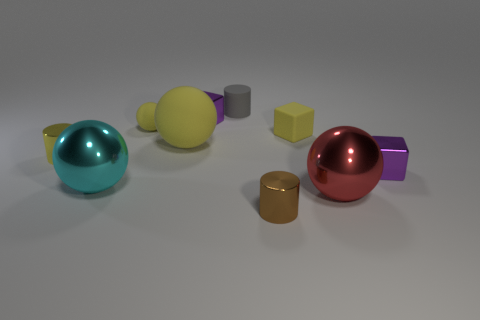There is a big object that is to the left of the large red sphere and in front of the big yellow rubber thing; what material is it made of?
Ensure brevity in your answer.  Metal. What shape is the gray matte object that is the same size as the brown metallic object?
Offer a terse response. Cylinder. What is the color of the tiny cylinder that is in front of the small purple shiny object that is right of the small gray cylinder behind the big rubber thing?
Your response must be concise. Brown. How many things are yellow rubber balls that are on the right side of the tiny sphere or large gray rubber spheres?
Provide a short and direct response. 1. There is a yellow cylinder that is the same size as the brown object; what material is it?
Your response must be concise. Metal. The cylinder that is behind the small yellow rubber thing to the right of the cylinder behind the small yellow rubber ball is made of what material?
Provide a short and direct response. Rubber. The small ball has what color?
Provide a short and direct response. Yellow. What number of small things are either yellow shiny cylinders or yellow balls?
Give a very brief answer. 2. What is the material of the tiny cylinder that is the same color as the big matte sphere?
Provide a short and direct response. Metal. Do the purple object on the right side of the small matte cylinder and the purple object that is to the left of the yellow rubber block have the same material?
Your response must be concise. Yes. 